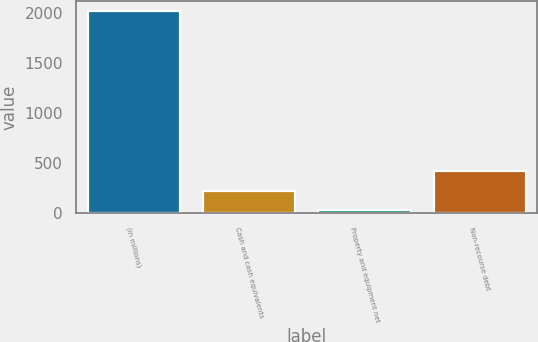Convert chart. <chart><loc_0><loc_0><loc_500><loc_500><bar_chart><fcel>(in millions)<fcel>Cash and cash equivalents<fcel>Property and equipment net<fcel>Non-recourse debt<nl><fcel>2013<fcel>224.7<fcel>26<fcel>423.4<nl></chart> 